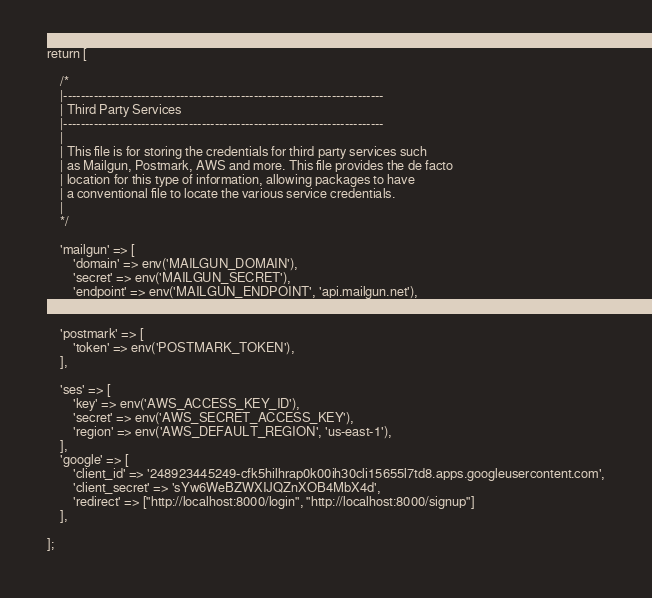Convert code to text. <code><loc_0><loc_0><loc_500><loc_500><_PHP_>return [

    /*
    |--------------------------------------------------------------------------
    | Third Party Services
    |--------------------------------------------------------------------------
    |
    | This file is for storing the credentials for third party services such
    | as Mailgun, Postmark, AWS and more. This file provides the de facto
    | location for this type of information, allowing packages to have
    | a conventional file to locate the various service credentials.
    |
    */

    'mailgun' => [
        'domain' => env('MAILGUN_DOMAIN'),
        'secret' => env('MAILGUN_SECRET'),
        'endpoint' => env('MAILGUN_ENDPOINT', 'api.mailgun.net'),
    ],

    'postmark' => [
        'token' => env('POSTMARK_TOKEN'),
    ],

    'ses' => [
        'key' => env('AWS_ACCESS_KEY_ID'),
        'secret' => env('AWS_SECRET_ACCESS_KEY'),
        'region' => env('AWS_DEFAULT_REGION', 'us-east-1'),
    ],
    'google' => [
        'client_id' => '248923445249-cfk5hilhrap0k00ih30cli15655l7td8.apps.googleusercontent.com',
        'client_secret' => 'sYw6WeBZWXIJQZnXOB4MbX4d',
        'redirect' => ["http://localhost:8000/login", "http://localhost:8000/signup"]
    ],

];
</code> 